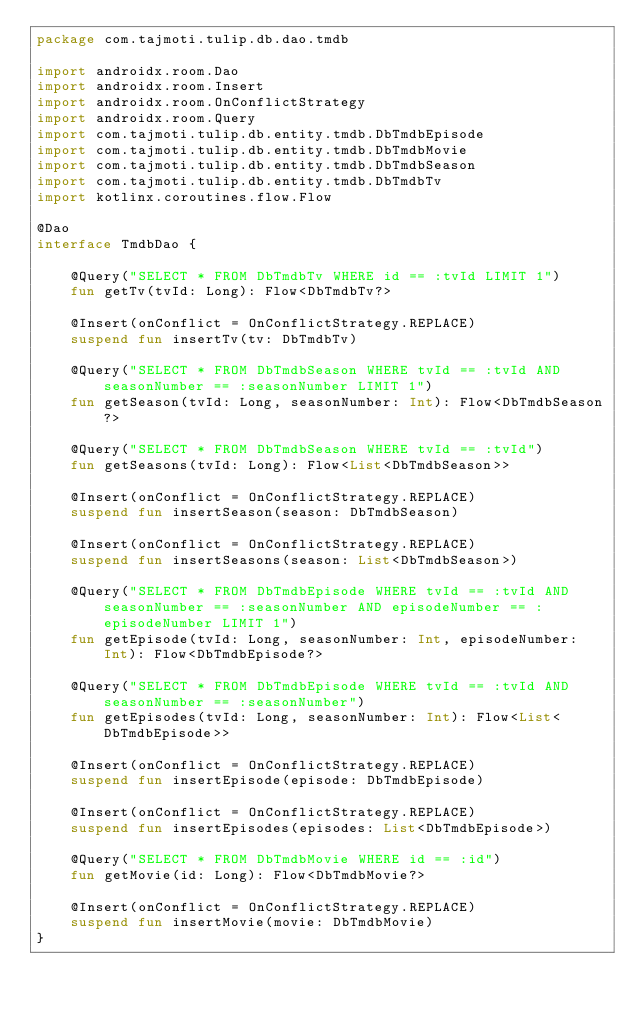Convert code to text. <code><loc_0><loc_0><loc_500><loc_500><_Kotlin_>package com.tajmoti.tulip.db.dao.tmdb

import androidx.room.Dao
import androidx.room.Insert
import androidx.room.OnConflictStrategy
import androidx.room.Query
import com.tajmoti.tulip.db.entity.tmdb.DbTmdbEpisode
import com.tajmoti.tulip.db.entity.tmdb.DbTmdbMovie
import com.tajmoti.tulip.db.entity.tmdb.DbTmdbSeason
import com.tajmoti.tulip.db.entity.tmdb.DbTmdbTv
import kotlinx.coroutines.flow.Flow

@Dao
interface TmdbDao {

    @Query("SELECT * FROM DbTmdbTv WHERE id == :tvId LIMIT 1")
    fun getTv(tvId: Long): Flow<DbTmdbTv?>

    @Insert(onConflict = OnConflictStrategy.REPLACE)
    suspend fun insertTv(tv: DbTmdbTv)

    @Query("SELECT * FROM DbTmdbSeason WHERE tvId == :tvId AND seasonNumber == :seasonNumber LIMIT 1")
    fun getSeason(tvId: Long, seasonNumber: Int): Flow<DbTmdbSeason?>

    @Query("SELECT * FROM DbTmdbSeason WHERE tvId == :tvId")
    fun getSeasons(tvId: Long): Flow<List<DbTmdbSeason>>

    @Insert(onConflict = OnConflictStrategy.REPLACE)
    suspend fun insertSeason(season: DbTmdbSeason)

    @Insert(onConflict = OnConflictStrategy.REPLACE)
    suspend fun insertSeasons(season: List<DbTmdbSeason>)

    @Query("SELECT * FROM DbTmdbEpisode WHERE tvId == :tvId AND seasonNumber == :seasonNumber AND episodeNumber == :episodeNumber LIMIT 1")
    fun getEpisode(tvId: Long, seasonNumber: Int, episodeNumber: Int): Flow<DbTmdbEpisode?>

    @Query("SELECT * FROM DbTmdbEpisode WHERE tvId == :tvId AND seasonNumber == :seasonNumber")
    fun getEpisodes(tvId: Long, seasonNumber: Int): Flow<List<DbTmdbEpisode>>

    @Insert(onConflict = OnConflictStrategy.REPLACE)
    suspend fun insertEpisode(episode: DbTmdbEpisode)

    @Insert(onConflict = OnConflictStrategy.REPLACE)
    suspend fun insertEpisodes(episodes: List<DbTmdbEpisode>)

    @Query("SELECT * FROM DbTmdbMovie WHERE id == :id")
    fun getMovie(id: Long): Flow<DbTmdbMovie?>

    @Insert(onConflict = OnConflictStrategy.REPLACE)
    suspend fun insertMovie(movie: DbTmdbMovie)
}
</code> 